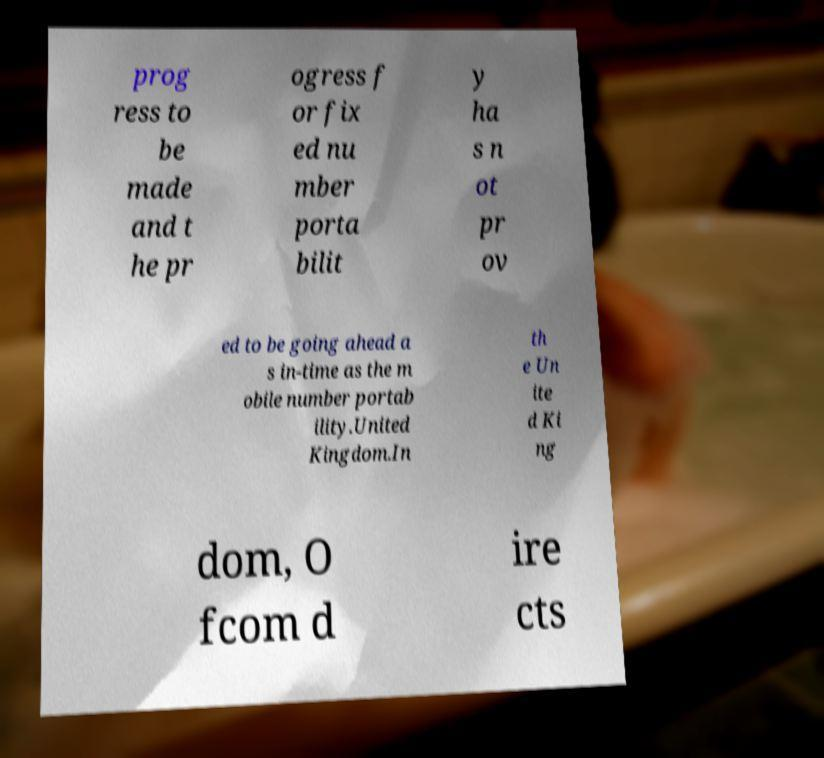Could you assist in decoding the text presented in this image and type it out clearly? prog ress to be made and t he pr ogress f or fix ed nu mber porta bilit y ha s n ot pr ov ed to be going ahead a s in-time as the m obile number portab ility.United Kingdom.In th e Un ite d Ki ng dom, O fcom d ire cts 